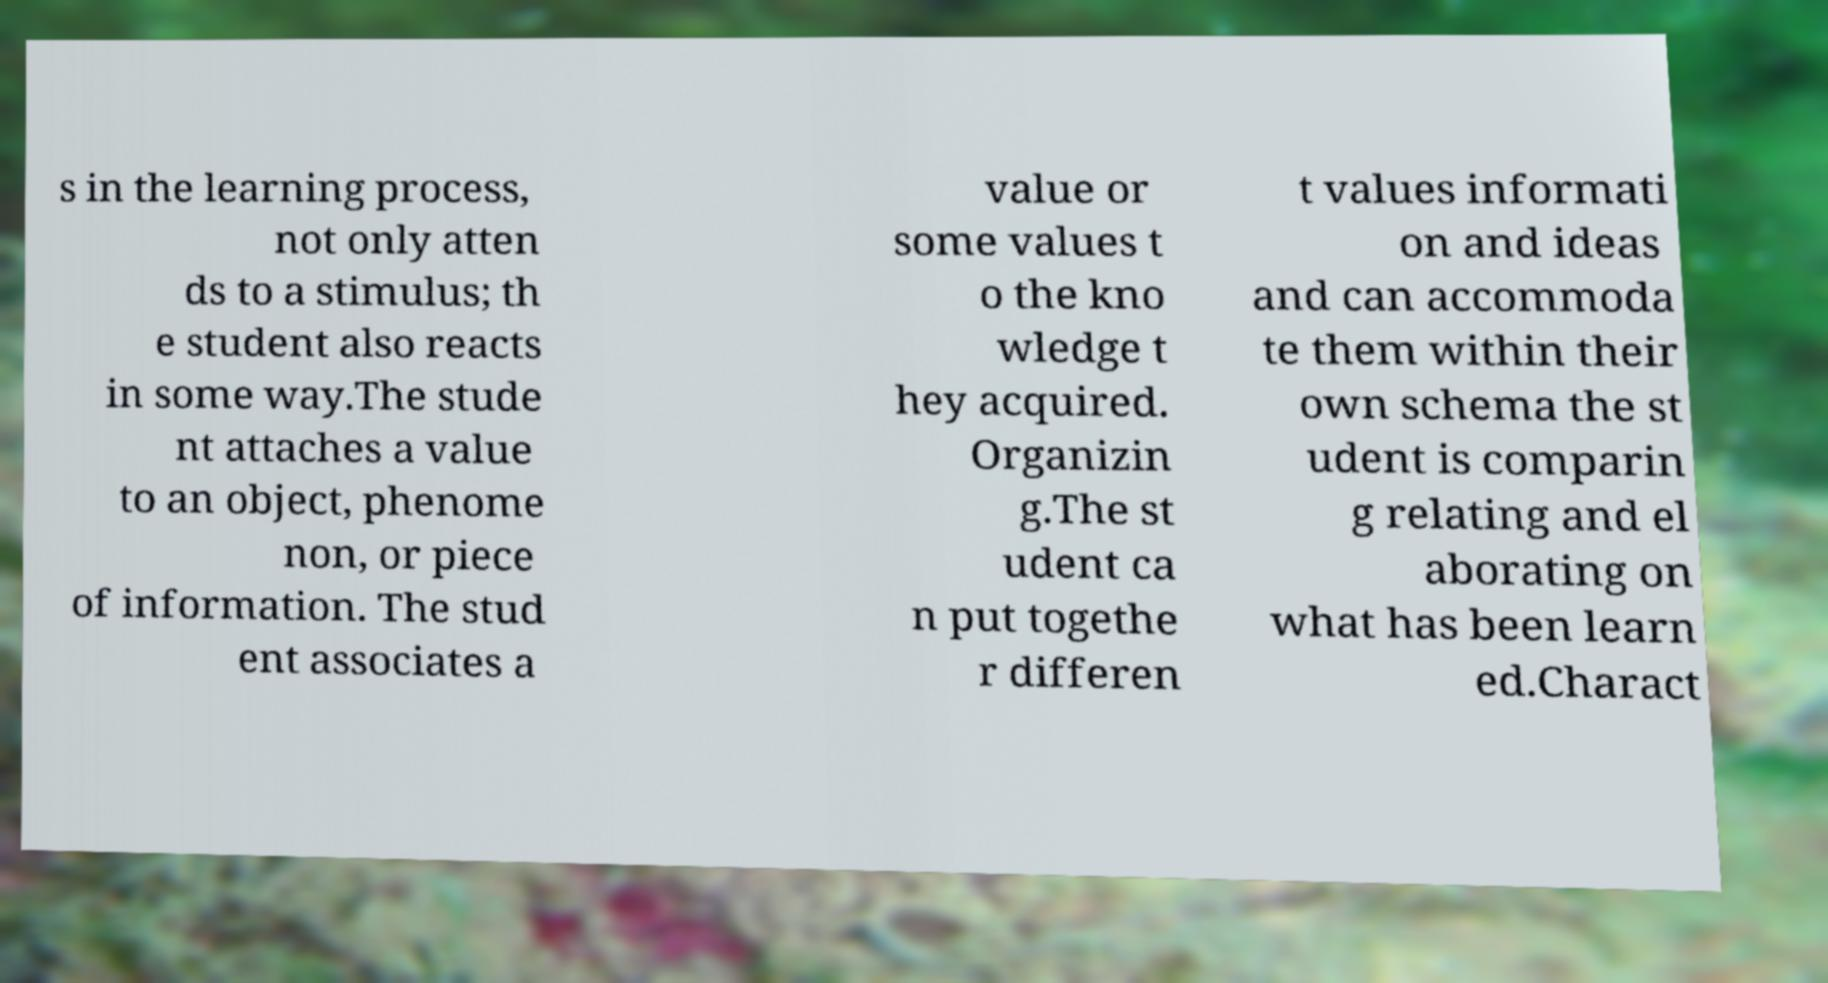I need the written content from this picture converted into text. Can you do that? s in the learning process, not only atten ds to a stimulus; th e student also reacts in some way.The stude nt attaches a value to an object, phenome non, or piece of information. The stud ent associates a value or some values t o the kno wledge t hey acquired. Organizin g.The st udent ca n put togethe r differen t values informati on and ideas and can accommoda te them within their own schema the st udent is comparin g relating and el aborating on what has been learn ed.Charact 